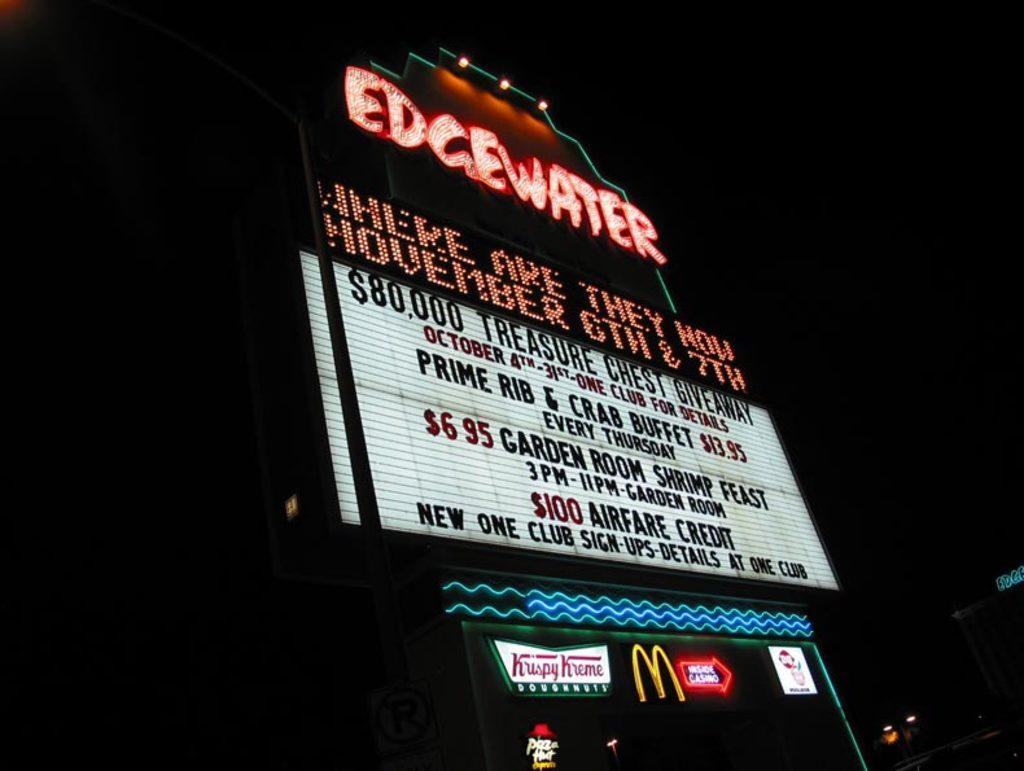<image>
Present a compact description of the photo's key features. A large neon sign that says Edgewater in red letters. 